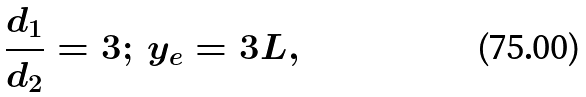Convert formula to latex. <formula><loc_0><loc_0><loc_500><loc_500>\frac { d _ { 1 } } { d _ { 2 } } = 3 ; \, y _ { e } = 3 L ,</formula> 